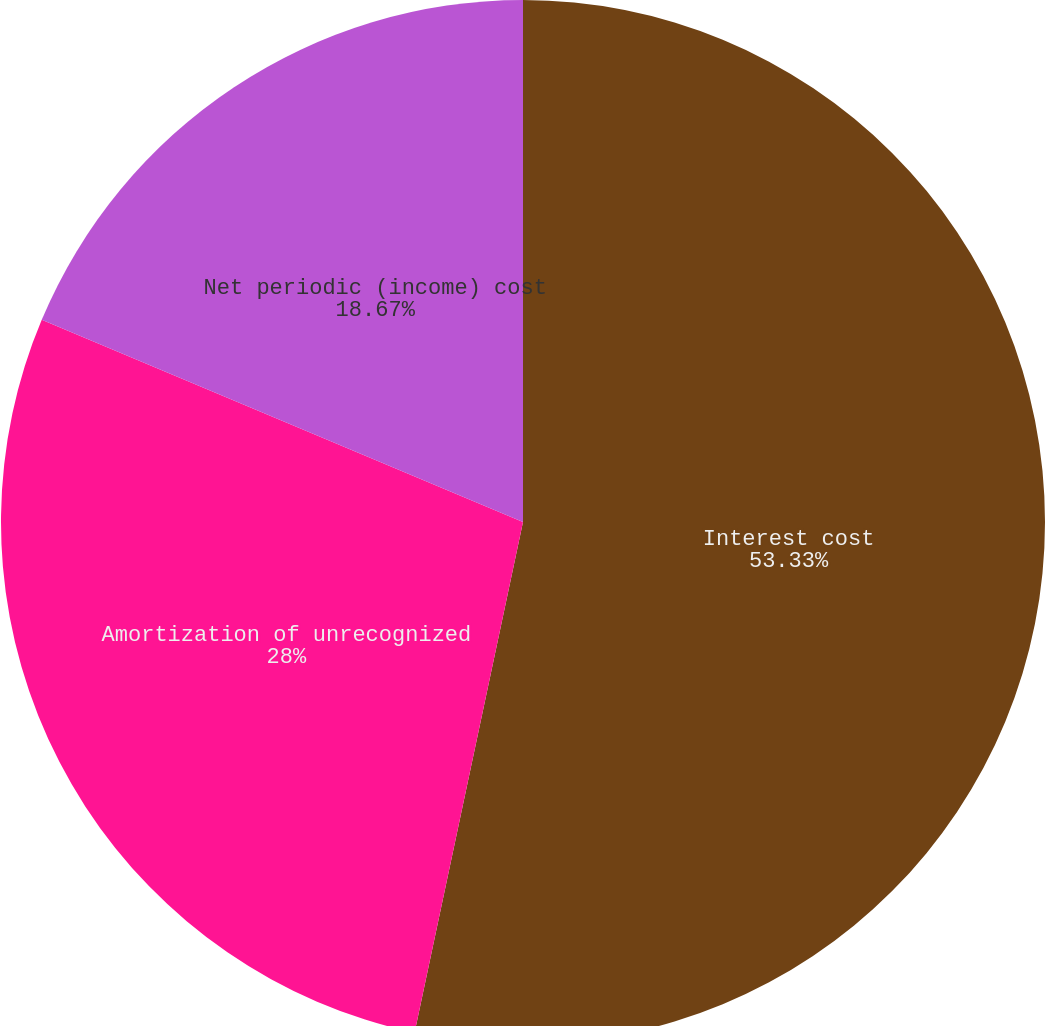<chart> <loc_0><loc_0><loc_500><loc_500><pie_chart><fcel>Interest cost<fcel>Amortization of unrecognized<fcel>Net periodic (income) cost<nl><fcel>53.33%<fcel>28.0%<fcel>18.67%<nl></chart> 